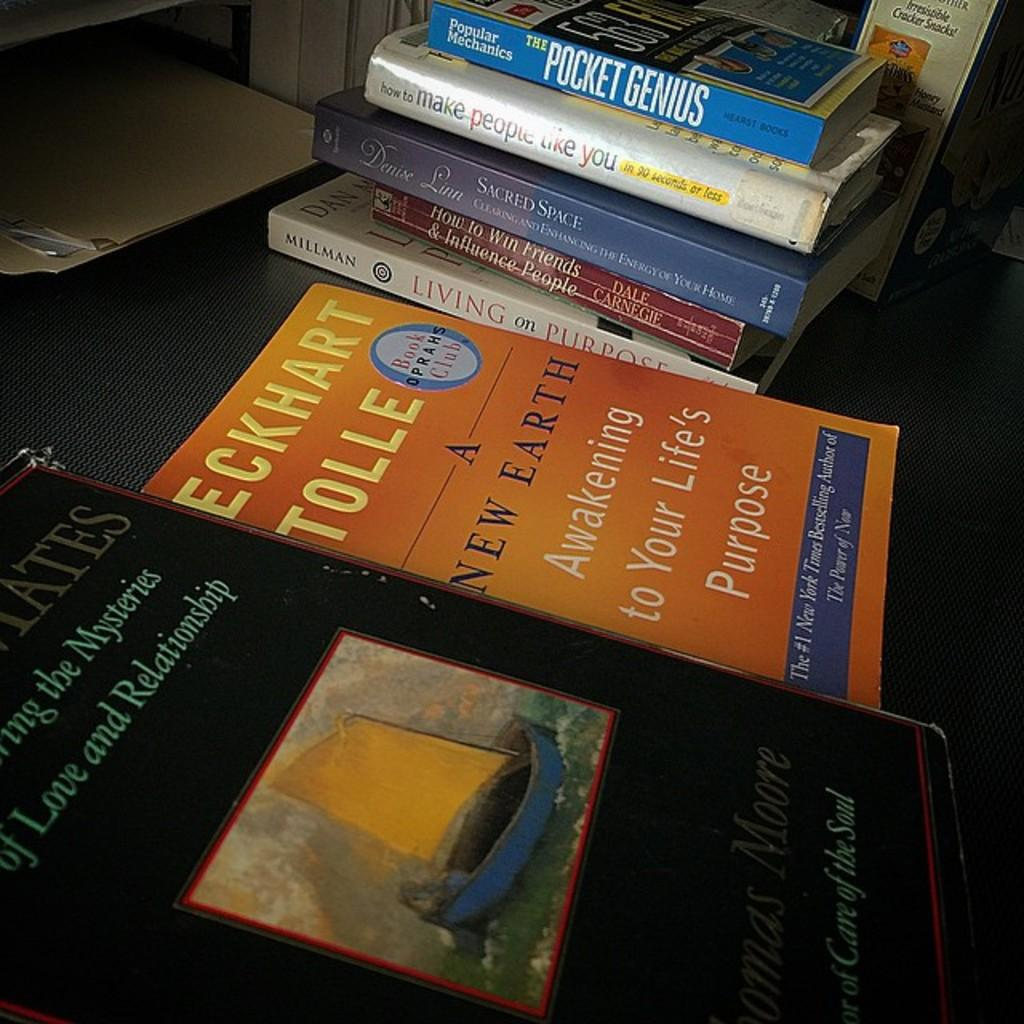<image>
Share a concise interpretation of the image provided. books around each other with one of them by eckhart tolle 